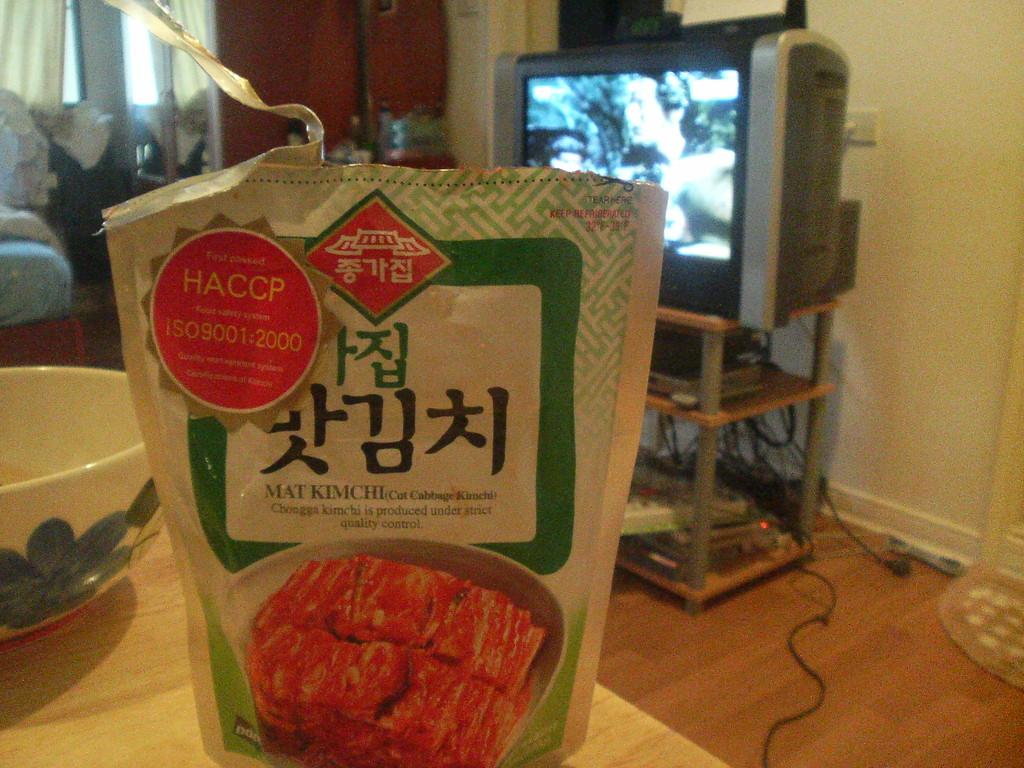What type of food is this?
Ensure brevity in your answer.  Kimchi. What is the last 4 digits of the number in the circle?
Keep it short and to the point. 2000. 